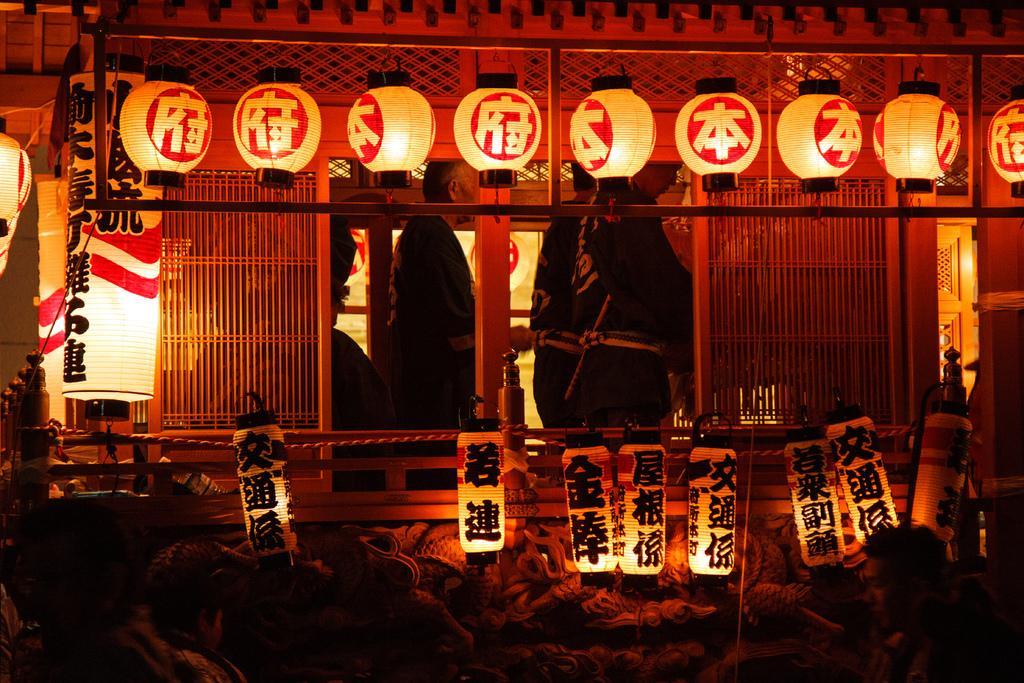In one or two sentences, can you explain what this image depicts? In this image we can see group of persons are standing, at above there are lights, there are some objects, there it is dark. 